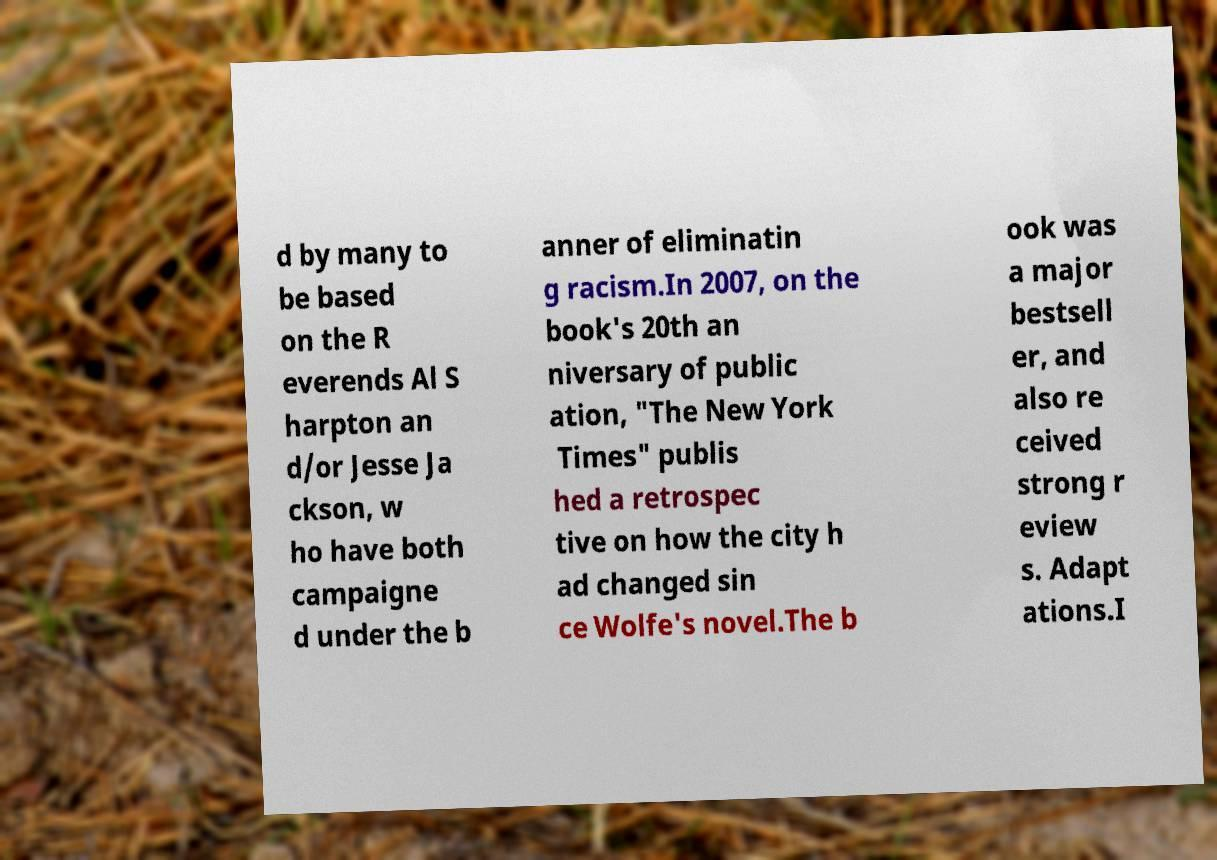Please identify and transcribe the text found in this image. d by many to be based on the R everends Al S harpton an d/or Jesse Ja ckson, w ho have both campaigne d under the b anner of eliminatin g racism.In 2007, on the book's 20th an niversary of public ation, "The New York Times" publis hed a retrospec tive on how the city h ad changed sin ce Wolfe's novel.The b ook was a major bestsell er, and also re ceived strong r eview s. Adapt ations.I 